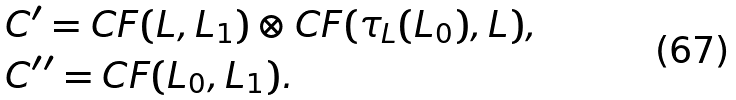Convert formula to latex. <formula><loc_0><loc_0><loc_500><loc_500>& C ^ { \prime } = C F ( L , L _ { 1 } ) \otimes C F ( \tau _ { L } ( L _ { 0 } ) , L ) , \\ & C ^ { \prime \prime } = C F ( L _ { 0 } , L _ { 1 } ) .</formula> 